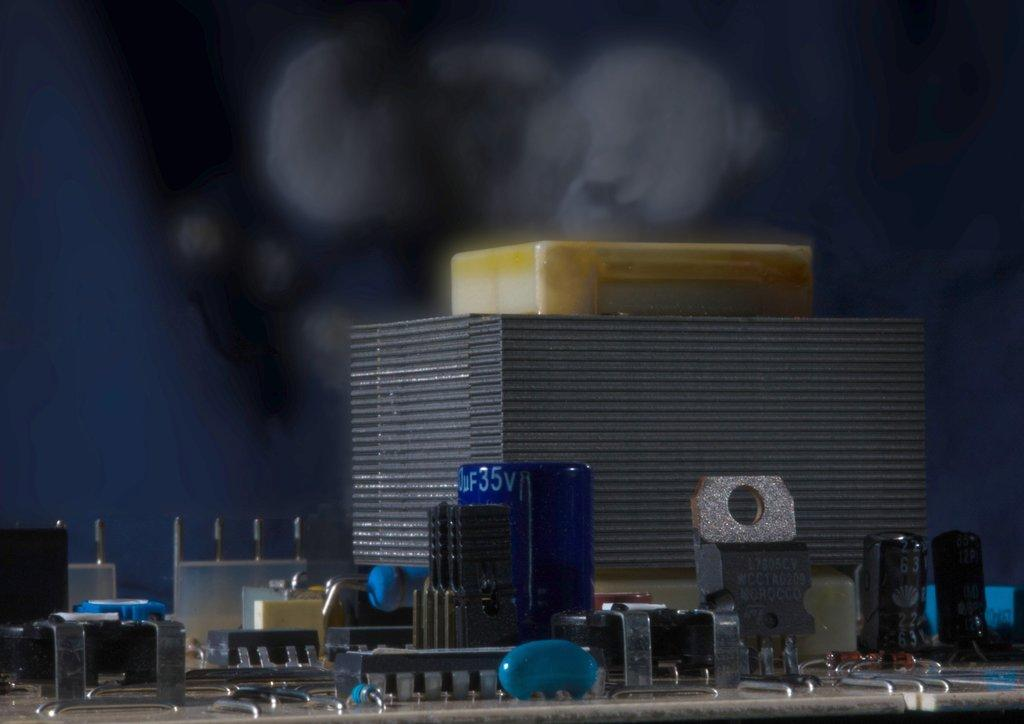What type of objects are featured in the image? The image contains electronic circuits, alphabets, and numbers. Can you describe the background of the image? The background of the image is dark. What type of glass is being used to create shade in the image? There is no glass or shade present in the image; it features electronic circuits, alphabets, and numbers with a dark background. 